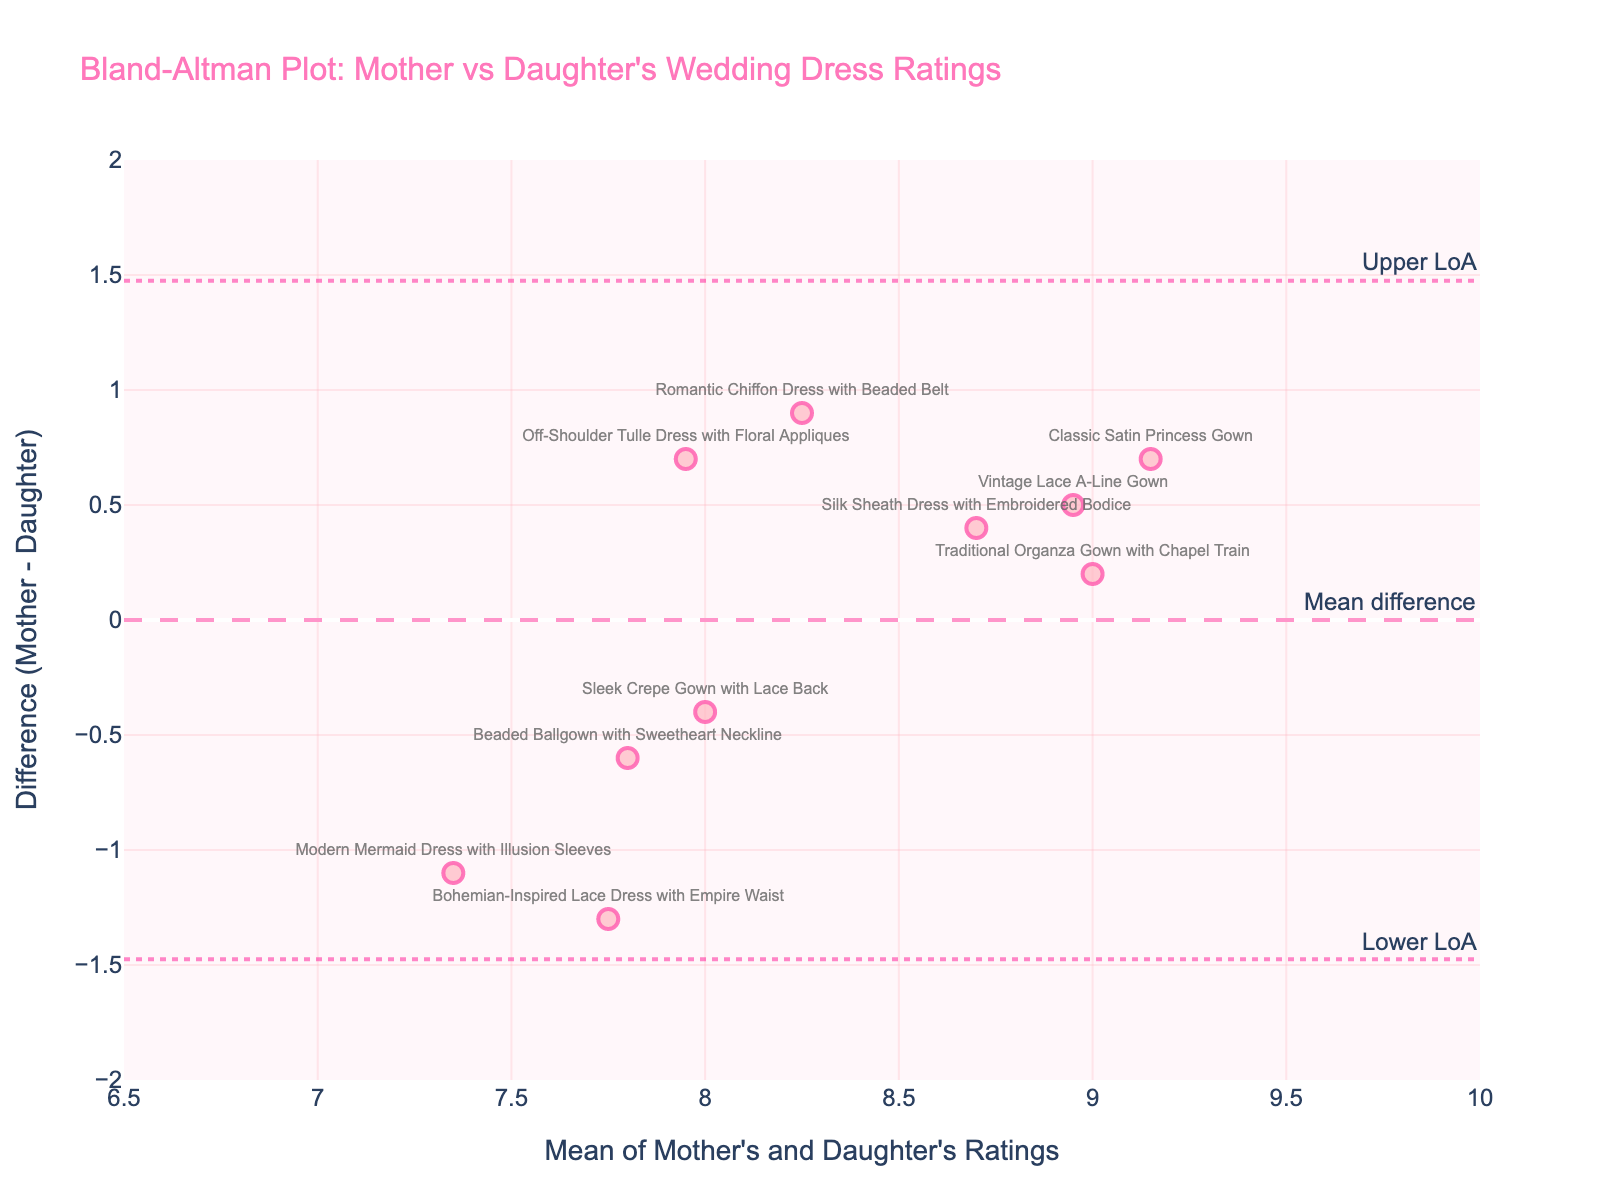What is the title of the plot? The title of the plot is usually displayed at the top. In this case, it reads "Bland-Altman Plot: Mother vs Daughter's Wedding Dress Ratings."
Answer: Bland-Altman Plot: Mother vs Daughter's Wedding Dress Ratings How many wedding dress designs were rated? Each data point on the plot represents a wedding dress design. Counting all the data points visualized gives the total number of designs rated.
Answer: 10 What do the dashed lines represent on the plot? There are typically horizontal dashed lines in a Bland-Altman plot: one represents the mean difference, and the other two denote the upper and lower limits of agreement (LoA).
Answer: Mean difference, Upper and Lower LoA Which dress design had the largest positive difference between the mother's and daughter's ratings? Looking at the vertical position of each point, the highest positive difference is where the point is farthest above the zero line on the y-axis. The hover text will show that "Bohemian-Inspired Lace Dress with Empire Waist" has the highest value.
Answer: Bohemian-Inspired Lace Dress with Empire Waist What is the range of the differences between ratings (Mother's rating minus Daughter's rating)? To find the range, look at the lowest and highest y-values, which represent the smallest and largest differences. The lowest visible difference is approximately -1.3, and the highest is around 1.3.
Answer: [-1.3, 1.3] What is the mean difference between the mother’s and daughter’s ratings? Look for the mean difference line, typically annotated on the plot. Hover text or an annotation might specify it. In this plot, this line is labeled near y = 0.4.
Answer: 0.4 In terms of agreement, how does the mother's preference for "Classic Satin Princess Gown" compare to the daughter's rating? Check the hover text for the "Classic Satin Princess Gown" point, then look at the y-axis value for its vertical position. This specific design has a mean difference that is slightly positive, indicating the mother rated it slightly higher than the daughter.
Answer: Mother's rating is slightly higher Which design has the biggest negative difference between the mother's and daughter's ratings? Find the lowest point in the plot below the zero line. This would be the point with the largest negative difference. Hover text indicates that "Off-Shoulder Tulle Dress with Floral Appliques" has the lowest negative value.
Answer: Off-Shoulder Tulle Dress with Floral Appliques What can be inferred if a data point is on the mean difference line? A data point on the mean difference line indicates that the difference between the mother’s and daughter’s ratings for that dress design is equal to the average difference across all ratings.
Answer: Difference is equal to the mean difference How do the limits of agreement (LoA) help in interpreting the plot? The limits of agreement (upper and lower) provide a range within which most differences between ratings are expected to lie. They help assess the consistency and agreement between the mother’s and daughter’s ratings. Points outside these limits indicate significant disagreement.
Answer: Help assess rating consistency and agreement 